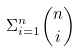<formula> <loc_0><loc_0><loc_500><loc_500>\Sigma _ { i = 1 } ^ { n } \binom { n } { i }</formula> 